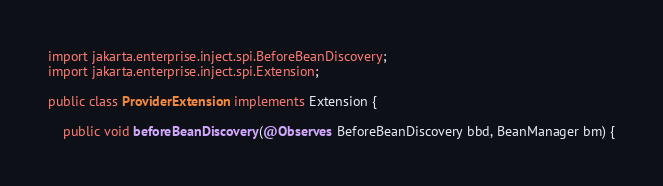<code> <loc_0><loc_0><loc_500><loc_500><_Java_>import jakarta.enterprise.inject.spi.BeforeBeanDiscovery;
import jakarta.enterprise.inject.spi.Extension;

public class ProviderExtension implements Extension {

    public void beforeBeanDiscovery(@Observes BeforeBeanDiscovery bbd, BeanManager bm) {</code> 